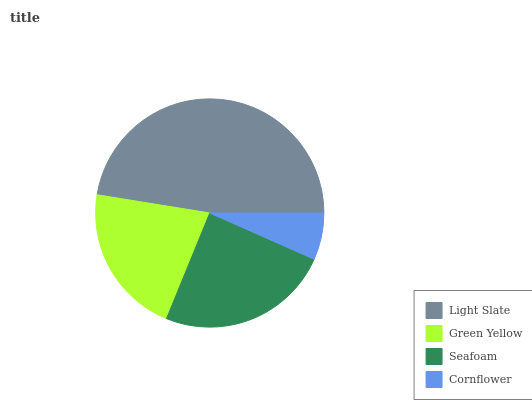Is Cornflower the minimum?
Answer yes or no. Yes. Is Light Slate the maximum?
Answer yes or no. Yes. Is Green Yellow the minimum?
Answer yes or no. No. Is Green Yellow the maximum?
Answer yes or no. No. Is Light Slate greater than Green Yellow?
Answer yes or no. Yes. Is Green Yellow less than Light Slate?
Answer yes or no. Yes. Is Green Yellow greater than Light Slate?
Answer yes or no. No. Is Light Slate less than Green Yellow?
Answer yes or no. No. Is Seafoam the high median?
Answer yes or no. Yes. Is Green Yellow the low median?
Answer yes or no. Yes. Is Green Yellow the high median?
Answer yes or no. No. Is Cornflower the low median?
Answer yes or no. No. 